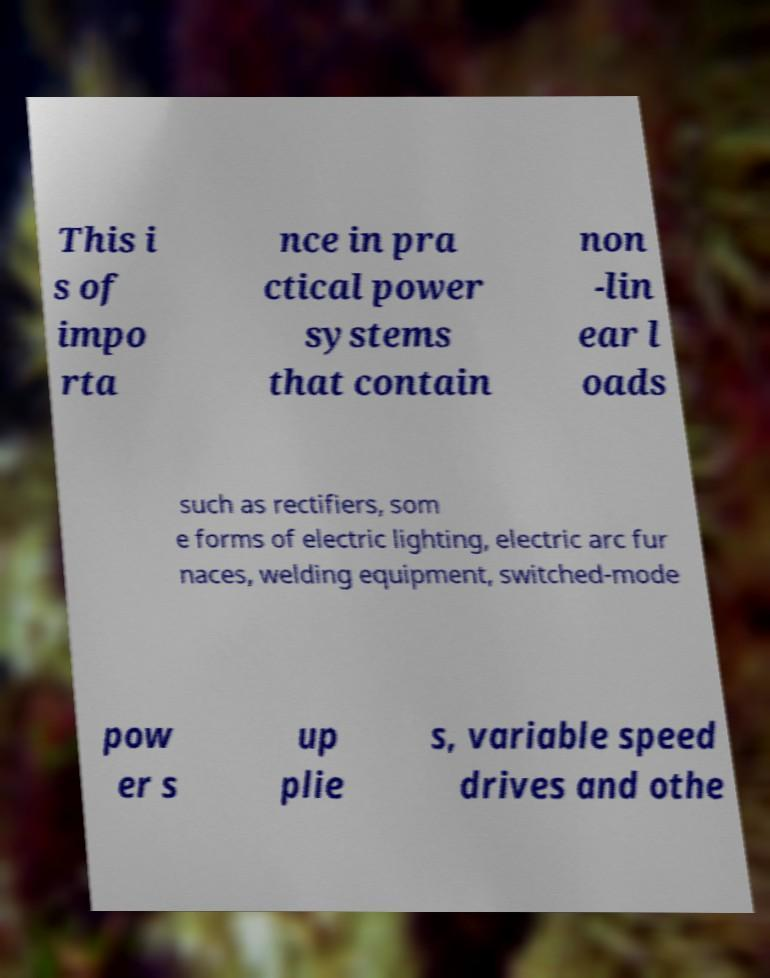For documentation purposes, I need the text within this image transcribed. Could you provide that? This i s of impo rta nce in pra ctical power systems that contain non -lin ear l oads such as rectifiers, som e forms of electric lighting, electric arc fur naces, welding equipment, switched-mode pow er s up plie s, variable speed drives and othe 